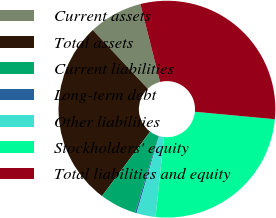Convert chart. <chart><loc_0><loc_0><loc_500><loc_500><pie_chart><fcel>Current assets<fcel>Total assets<fcel>Current liabilities<fcel>Long-term debt<fcel>Other liabilities<fcel>Stockholders' equity<fcel>Total liabilities and equity<nl><fcel>8.05%<fcel>27.81%<fcel>5.45%<fcel>0.24%<fcel>2.84%<fcel>25.2%<fcel>30.41%<nl></chart> 